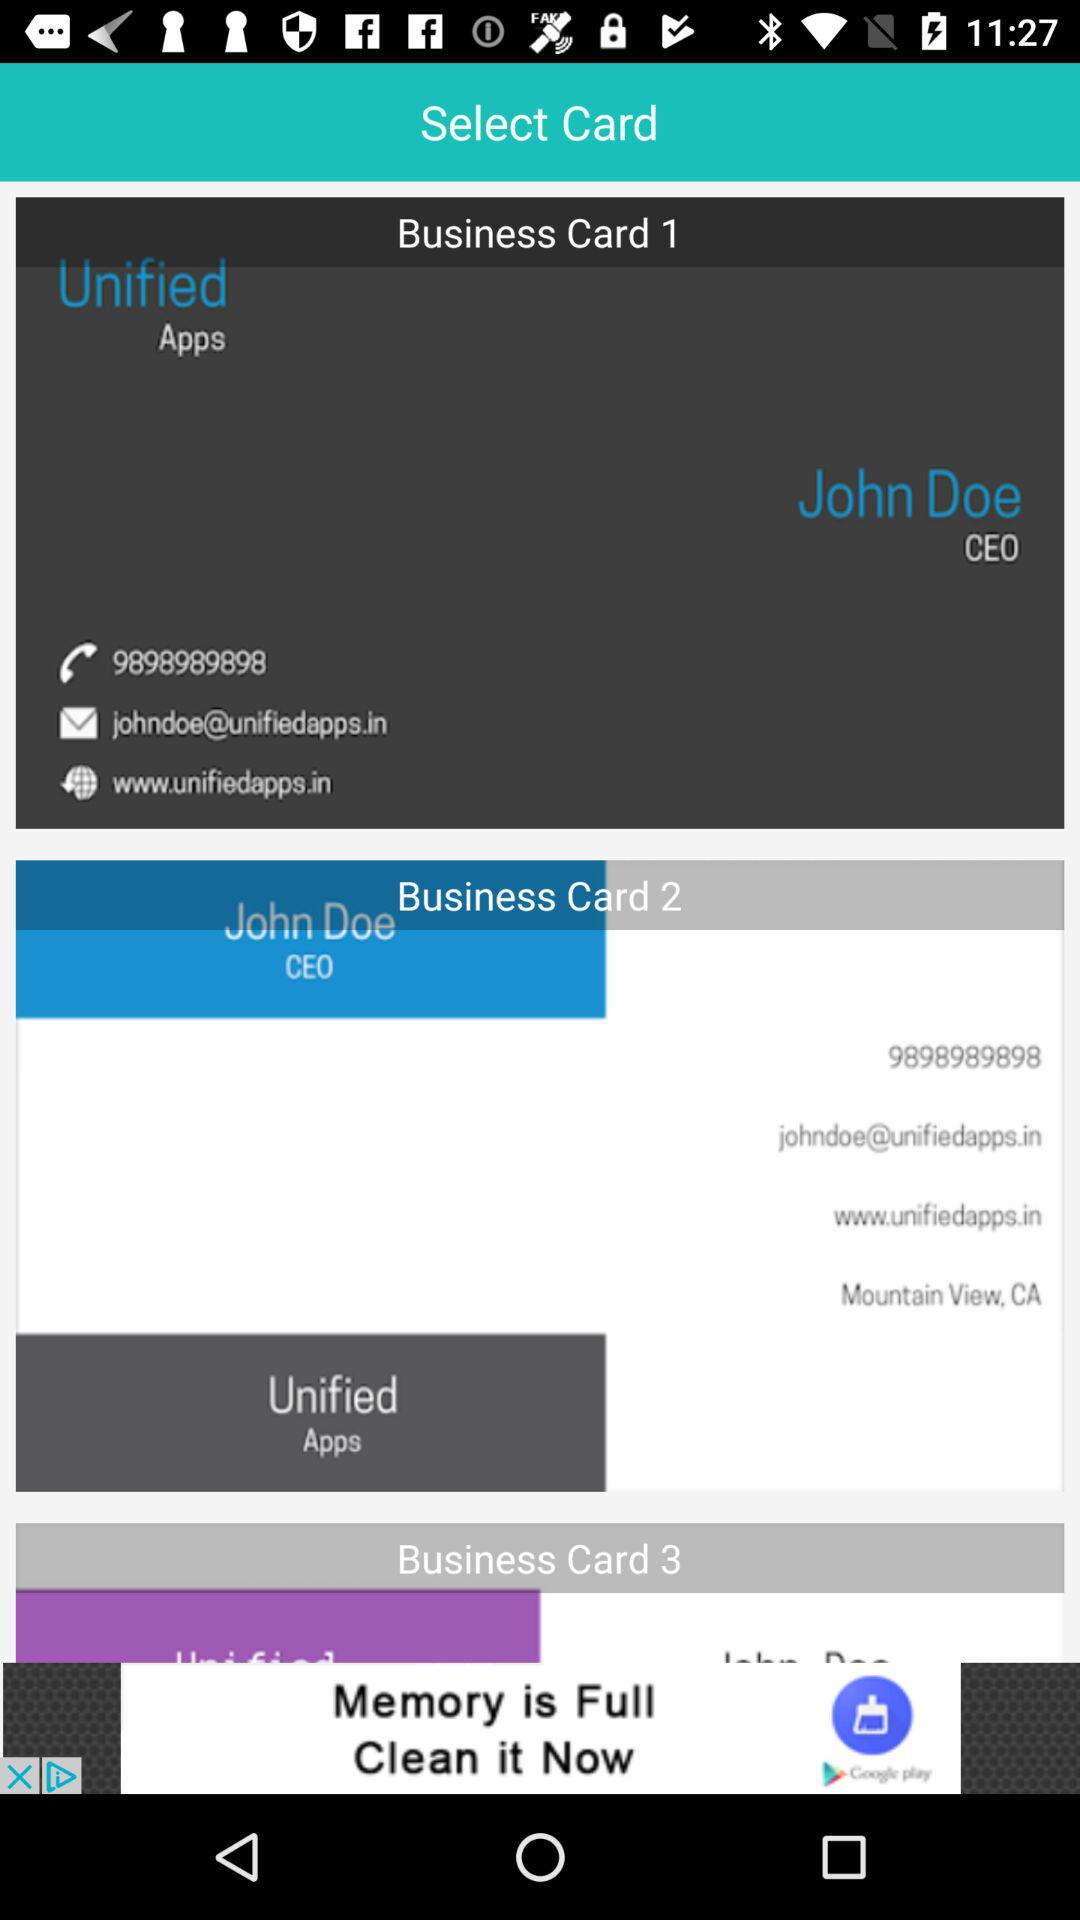What is the city's name? The city's name is Mountain View. 